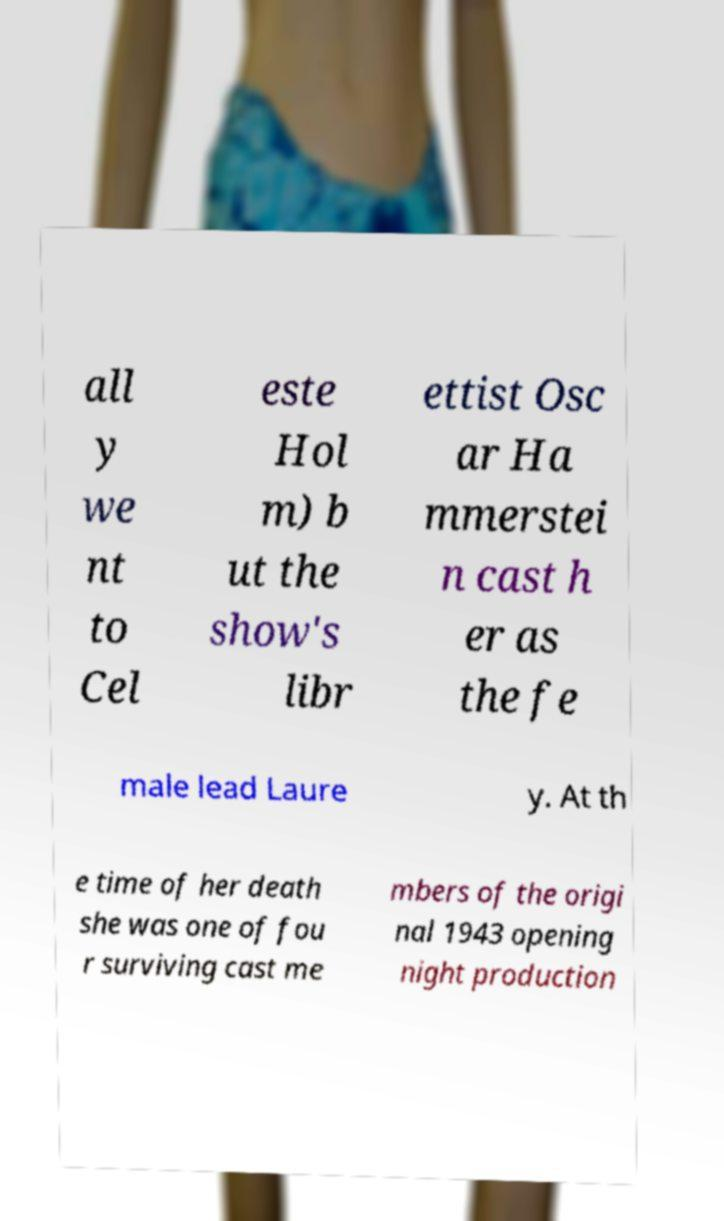Please identify and transcribe the text found in this image. all y we nt to Cel este Hol m) b ut the show's libr ettist Osc ar Ha mmerstei n cast h er as the fe male lead Laure y. At th e time of her death she was one of fou r surviving cast me mbers of the origi nal 1943 opening night production 